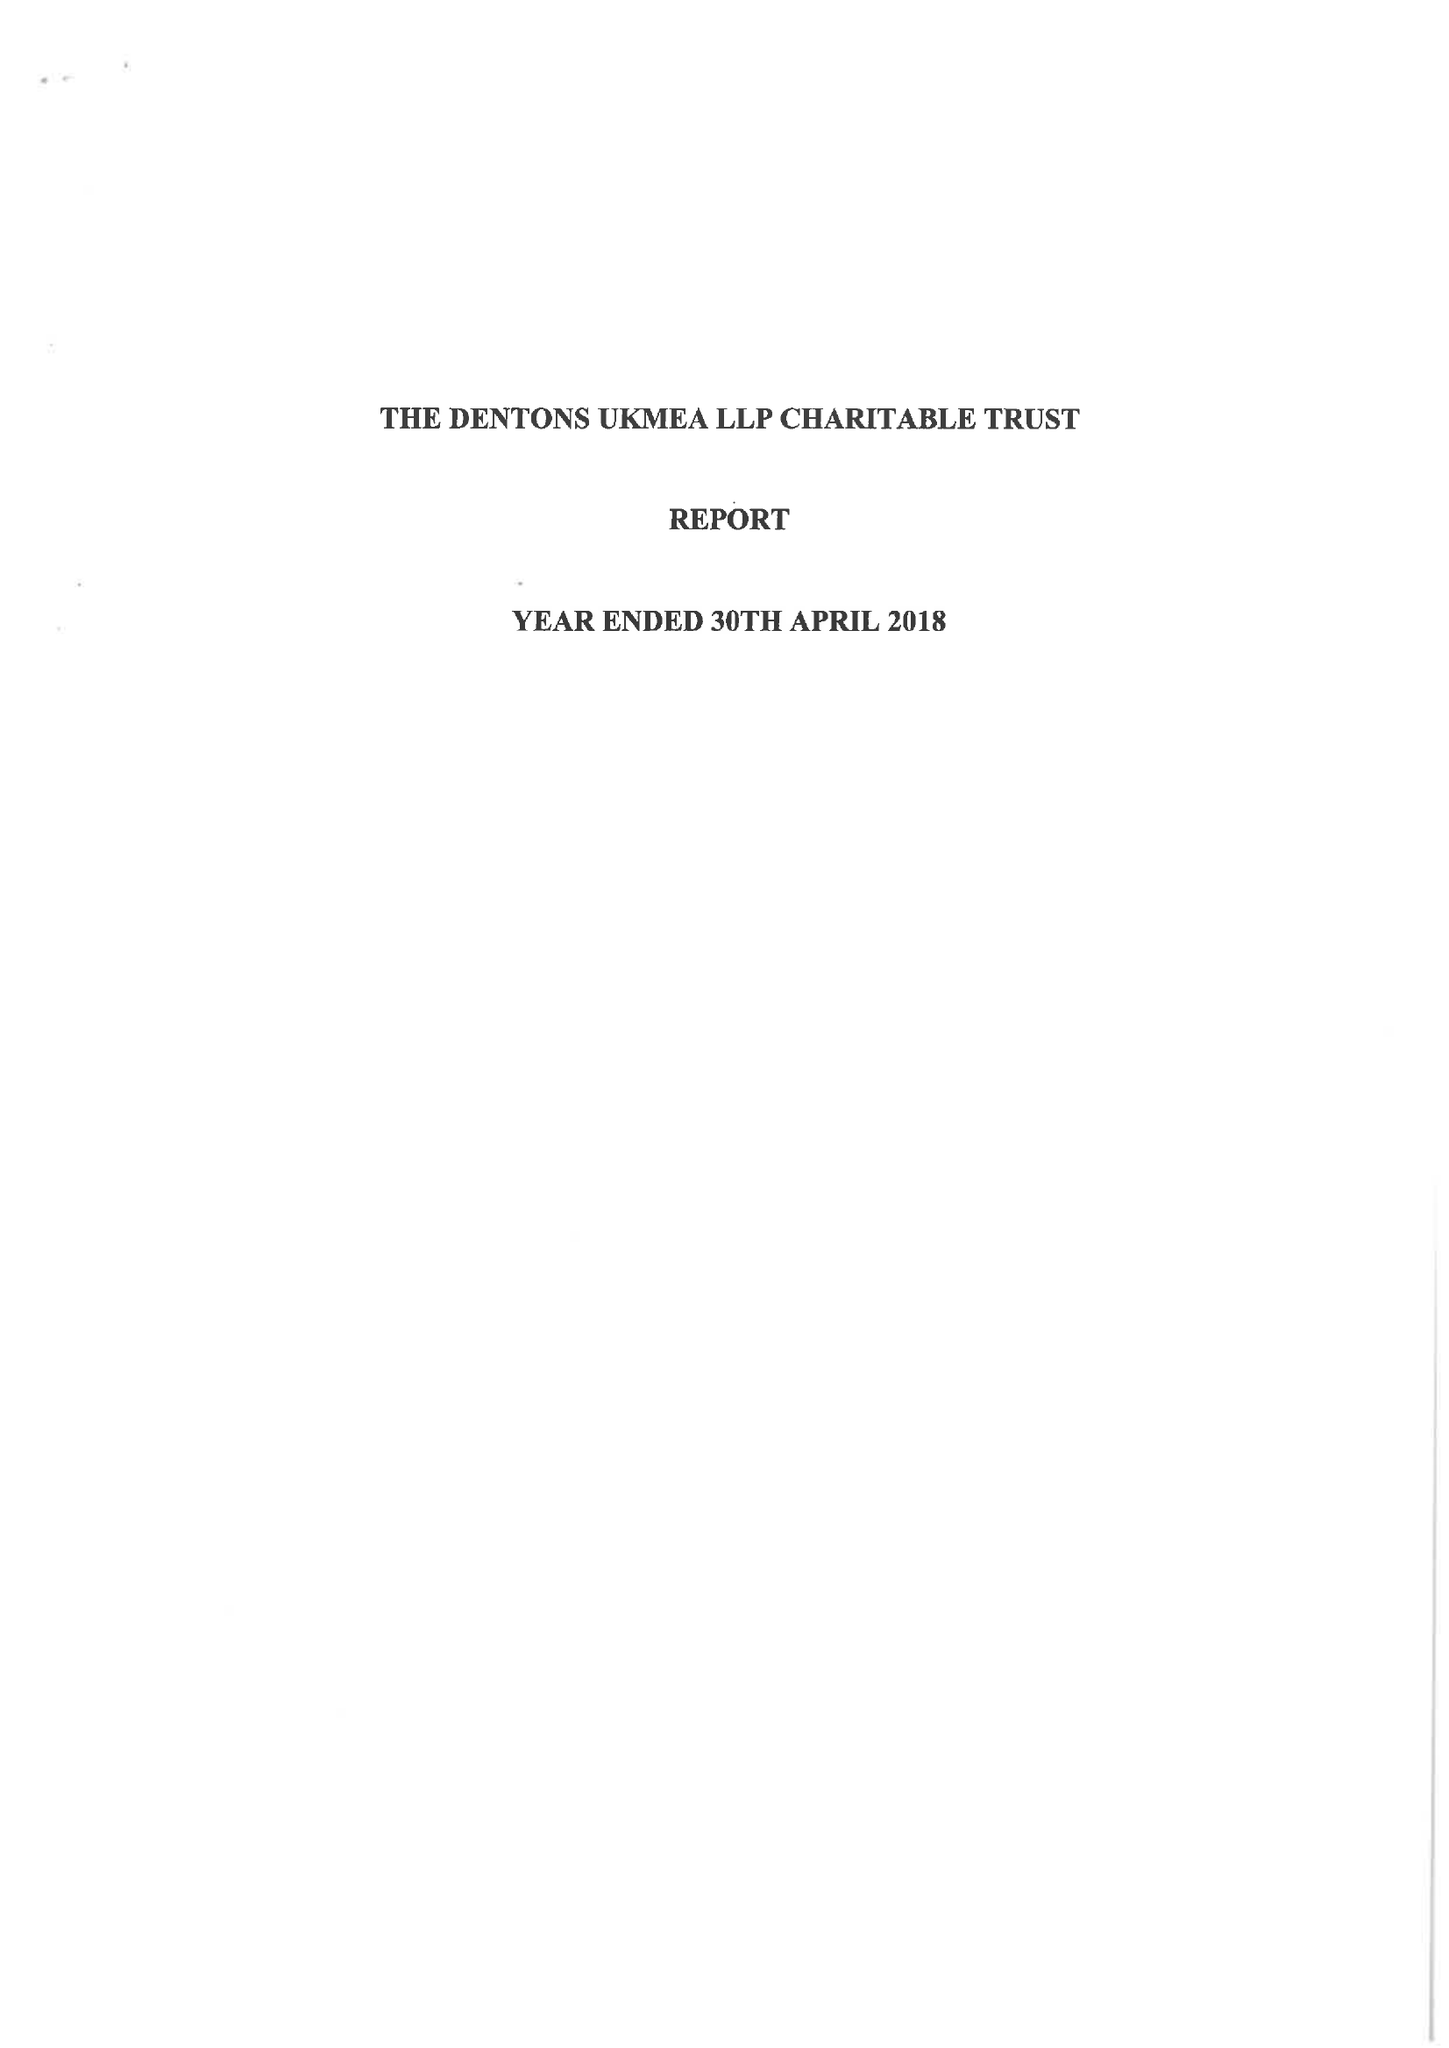What is the value for the address__postcode?
Answer the question using a single word or phrase. EC4M 7WS 